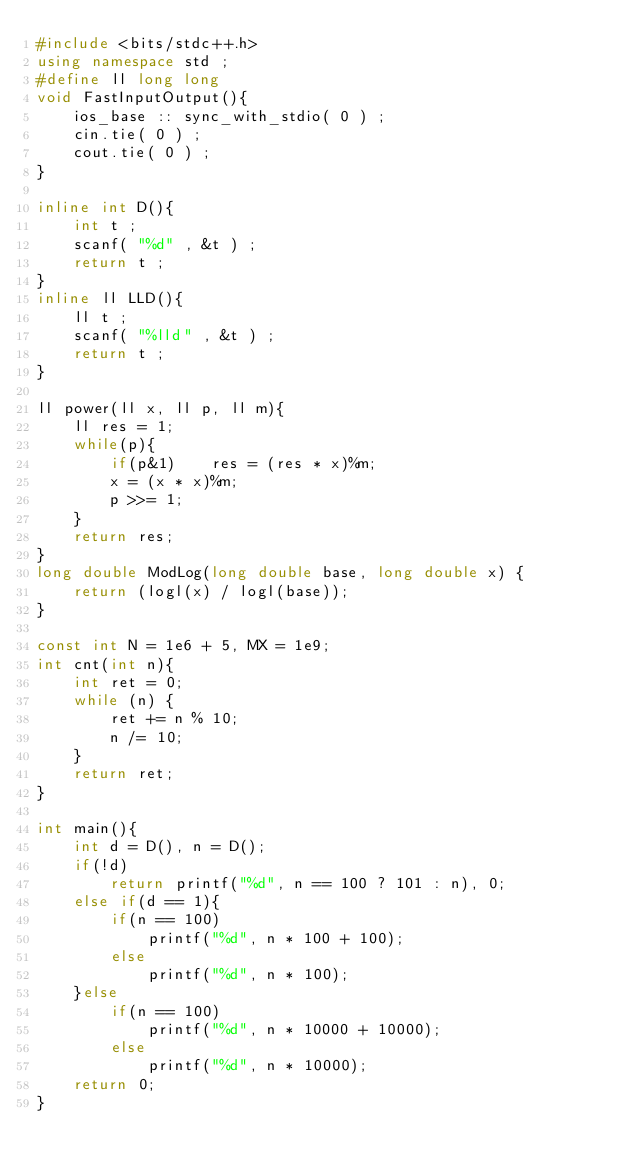Convert code to text. <code><loc_0><loc_0><loc_500><loc_500><_C++_>#include <bits/stdc++.h>
using namespace std ;
#define ll long long
void FastInputOutput(){
    ios_base :: sync_with_stdio( 0 ) ;
    cin.tie( 0 ) ;
    cout.tie( 0 ) ;
}

inline int D(){
    int t ;
    scanf( "%d" , &t ) ;
    return t ;
}
inline ll LLD(){
    ll t ;
    scanf( "%lld" , &t ) ;
    return t ;
}

ll power(ll x, ll p, ll m){
    ll res = 1;
    while(p){
        if(p&1)    res = (res * x)%m;
        x = (x * x)%m;
        p >>= 1;
    }
    return res;
}
long double ModLog(long double base, long double x) {
    return (logl(x) / logl(base));
}

const int N = 1e6 + 5, MX = 1e9;
int cnt(int n){
    int ret = 0;
    while (n) {
        ret += n % 10;
        n /= 10;
    }
    return ret;
}

int main(){
    int d = D(), n = D();
    if(!d)
        return printf("%d", n == 100 ? 101 : n), 0;
    else if(d == 1){
        if(n == 100)
            printf("%d", n * 100 + 100);
        else
            printf("%d", n * 100);
    }else
        if(n == 100)
            printf("%d", n * 10000 + 10000);
        else
            printf("%d", n * 10000);
    return 0;
}
</code> 